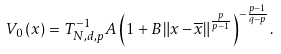<formula> <loc_0><loc_0><loc_500><loc_500>V _ { 0 } \left ( x \right ) = T _ { N , d , p } ^ { - 1 } A \left ( 1 + B \left \| x - \overline { x } \right \| ^ { \frac { p } { p - 1 } } \right ) ^ { - \frac { p - 1 } { q - p } } .</formula> 